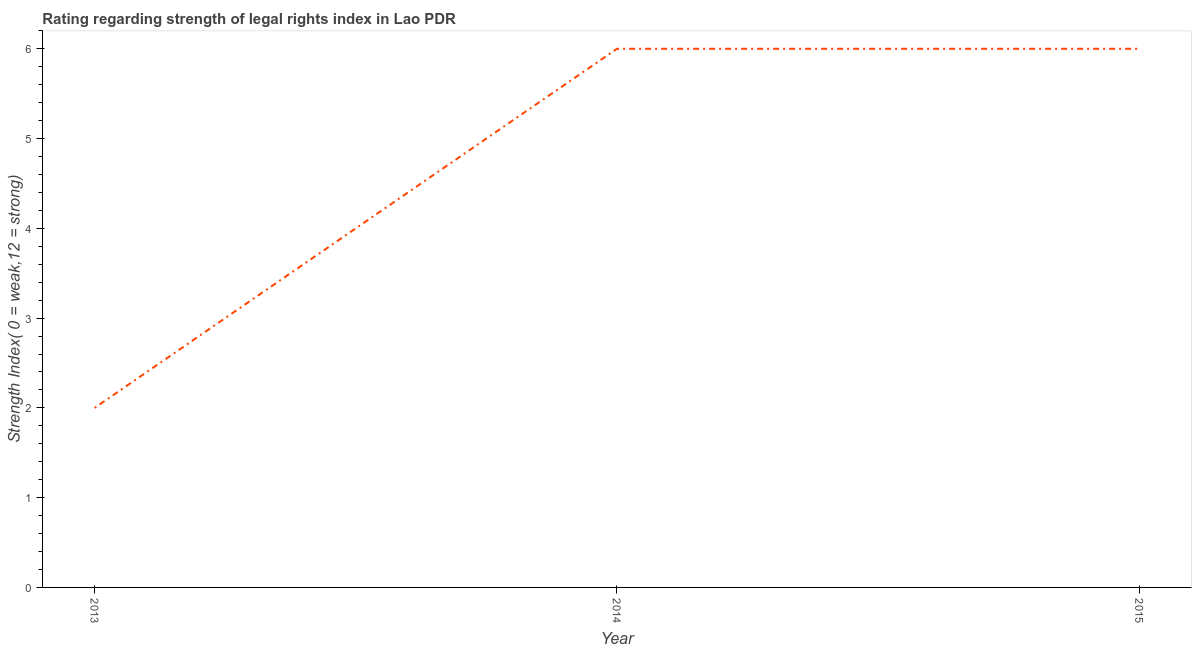Across all years, what is the minimum strength of legal rights index?
Ensure brevity in your answer.  2. What is the sum of the strength of legal rights index?
Provide a short and direct response. 14. What is the difference between the strength of legal rights index in 2014 and 2015?
Your answer should be compact. 0. What is the average strength of legal rights index per year?
Keep it short and to the point. 4.67. What is the median strength of legal rights index?
Provide a short and direct response. 6. In how many years, is the strength of legal rights index greater than 2.6 ?
Provide a succinct answer. 2. What is the ratio of the strength of legal rights index in 2013 to that in 2015?
Your answer should be compact. 0.33. Is the strength of legal rights index in 2013 less than that in 2014?
Provide a short and direct response. Yes. Is the difference between the strength of legal rights index in 2014 and 2015 greater than the difference between any two years?
Make the answer very short. No. What is the difference between the highest and the second highest strength of legal rights index?
Your response must be concise. 0. Is the sum of the strength of legal rights index in 2014 and 2015 greater than the maximum strength of legal rights index across all years?
Keep it short and to the point. Yes. What is the difference between the highest and the lowest strength of legal rights index?
Provide a short and direct response. 4. In how many years, is the strength of legal rights index greater than the average strength of legal rights index taken over all years?
Keep it short and to the point. 2. Does the strength of legal rights index monotonically increase over the years?
Provide a short and direct response. No. How many lines are there?
Make the answer very short. 1. How many years are there in the graph?
Make the answer very short. 3. What is the difference between two consecutive major ticks on the Y-axis?
Your answer should be compact. 1. Are the values on the major ticks of Y-axis written in scientific E-notation?
Ensure brevity in your answer.  No. Does the graph contain grids?
Your response must be concise. No. What is the title of the graph?
Offer a very short reply. Rating regarding strength of legal rights index in Lao PDR. What is the label or title of the X-axis?
Your response must be concise. Year. What is the label or title of the Y-axis?
Provide a succinct answer. Strength Index( 0 = weak,12 = strong). What is the Strength Index( 0 = weak,12 = strong) of 2014?
Ensure brevity in your answer.  6. What is the Strength Index( 0 = weak,12 = strong) of 2015?
Keep it short and to the point. 6. What is the difference between the Strength Index( 0 = weak,12 = strong) in 2013 and 2015?
Keep it short and to the point. -4. What is the ratio of the Strength Index( 0 = weak,12 = strong) in 2013 to that in 2014?
Ensure brevity in your answer.  0.33. What is the ratio of the Strength Index( 0 = weak,12 = strong) in 2013 to that in 2015?
Offer a terse response. 0.33. What is the ratio of the Strength Index( 0 = weak,12 = strong) in 2014 to that in 2015?
Offer a very short reply. 1. 